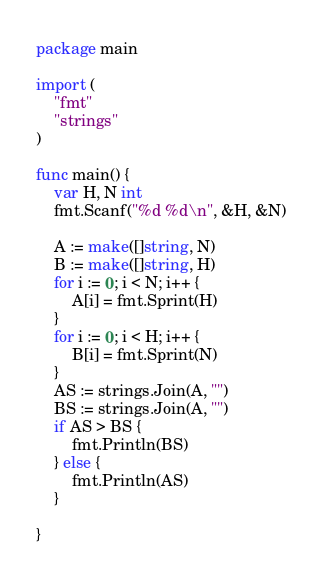Convert code to text. <code><loc_0><loc_0><loc_500><loc_500><_Go_>package main

import (
	"fmt"
	"strings"
)

func main() {
	var H, N int
	fmt.Scanf("%d %d\n", &H, &N)

	A := make([]string, N)
	B := make([]string, H)
	for i := 0; i < N; i++ {
		A[i] = fmt.Sprint(H)
	}
	for i := 0; i < H; i++ {
		B[i] = fmt.Sprint(N)
	}
	AS := strings.Join(A, "")
	BS := strings.Join(A, "")
	if AS > BS {
		fmt.Println(BS)
	} else {
		fmt.Println(AS)
	}

}
</code> 